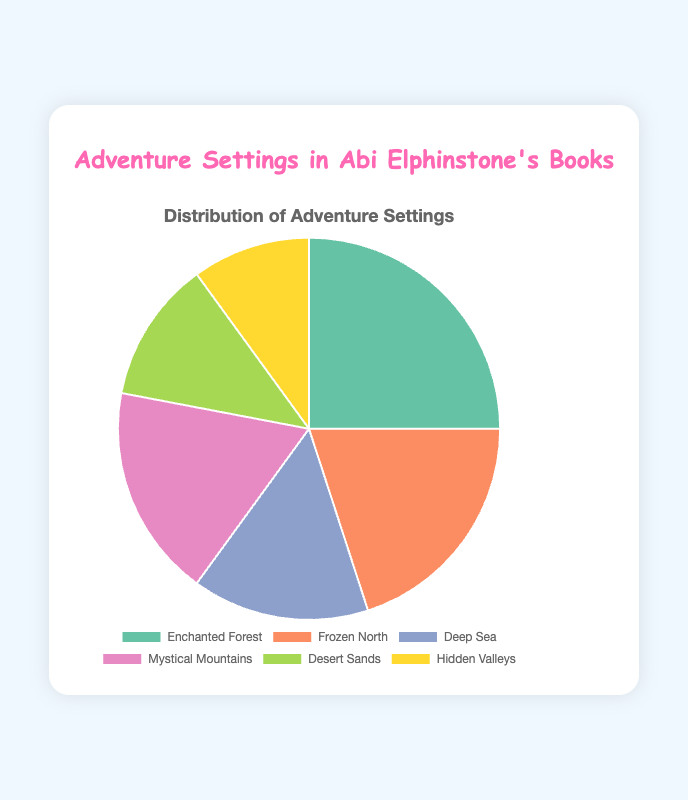What percentage of adventure settings take place in Enchanted Forest or Frozen North combined? To answer this, add the percentages for Enchanted Forest (25%) and Frozen North (20%). The total is 25% + 20% = 45%.
Answer: 45% Which setting has the lowest percentage? Examine the chart and identify the segment with the smallest percentage value. Hidden Valleys has the lowest percentage at 10%.
Answer: Hidden Valleys How much higher is the percentage of Enchanted Forest compared to Deep Sea? Subtract the percentage of Deep Sea (15%) from that of Enchanted Forest (25%). So, 25% - 15% = 10%.
Answer: 10% What is the average percentage of all adventure settings? Sum all the percentages (25% + 20% + 15% + 18% + 12% + 10% = 100%) and divide by the number of settings (6). The average is 100% / 6 ≈ 16.67%.
Answer: 16.67% Which two settings have a combined percentage of 30%? Look for two settings whose percentages add up to 30%. Desert Sands (12%) and Hidden Valleys (10%) combined give 12% + 18% = 30%.
Answer: Desert Sands and Hidden Valleys Which setting has the largest visual segment in the pie chart? Identify the segment that covers the largest area. Enchanted Forest is the largest with 25%.
Answer: Enchanted Forest How much more percentage does Mystical Mountains have than Desert Sands? Subtract the percentage of Desert Sands (12%) from Mystical Mountains (18%). The result is 18% - 12% = 6%.
Answer: 6% What is the combined percentage of the settings that are less than 20% each? Add the percentages of Frozen North (20%), Deep Sea (15%), Mystical Mountains (18%), Desert Sands (12%), and Hidden Valleys (10%). The cumulative total is 20% + 15% + 18% + 12% + 10% = 75%.
Answer: 75% 